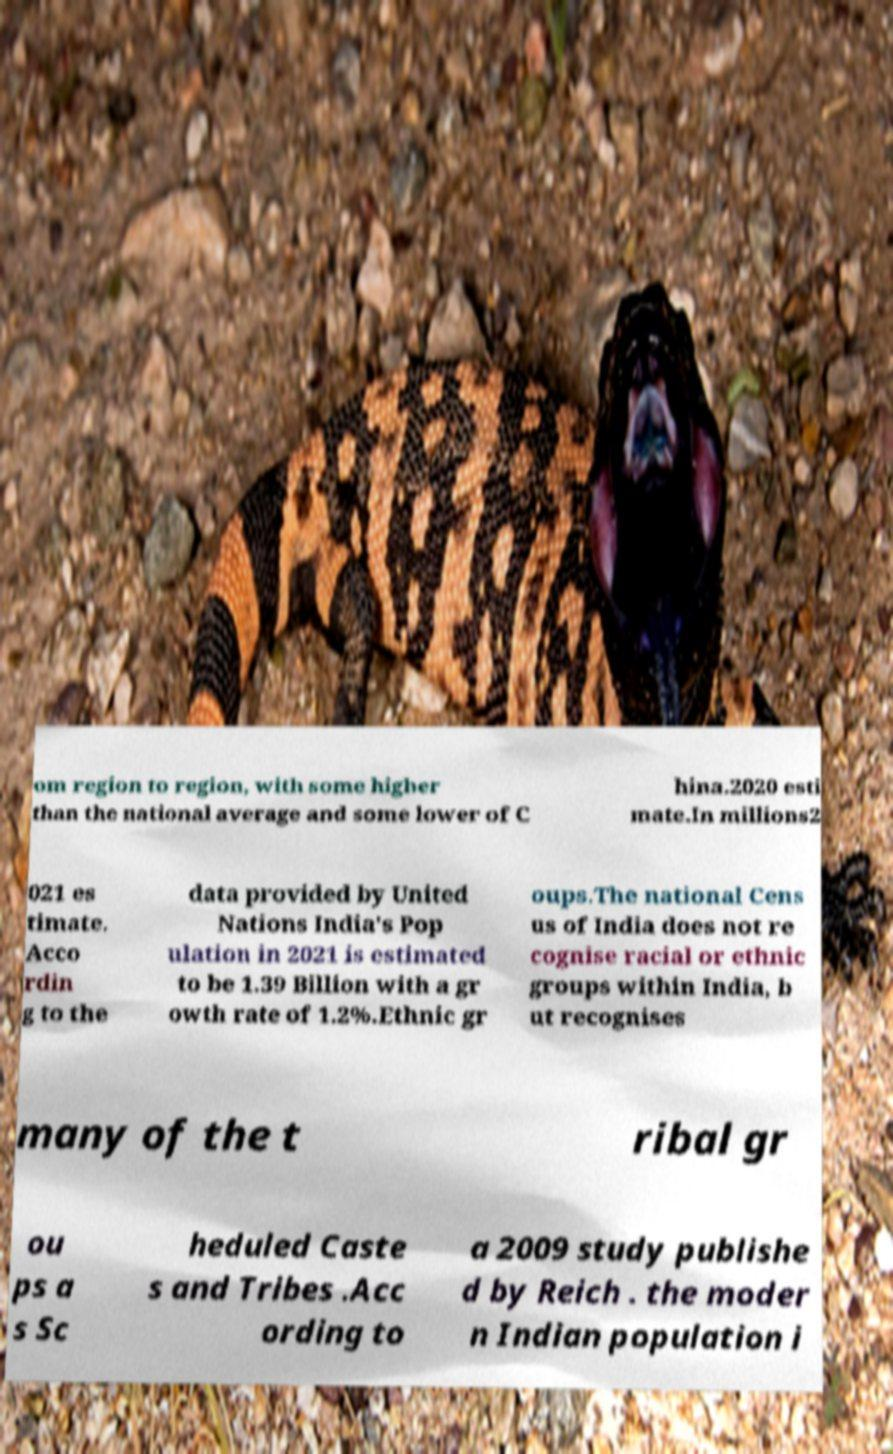There's text embedded in this image that I need extracted. Can you transcribe it verbatim? om region to region, with some higher than the national average and some lower of C hina.2020 esti mate.In millions2 021 es timate. Acco rdin g to the data provided by United Nations India's Pop ulation in 2021 is estimated to be 1.39 Billion with a gr owth rate of 1.2%.Ethnic gr oups.The national Cens us of India does not re cognise racial or ethnic groups within India, b ut recognises many of the t ribal gr ou ps a s Sc heduled Caste s and Tribes .Acc ording to a 2009 study publishe d by Reich . the moder n Indian population i 